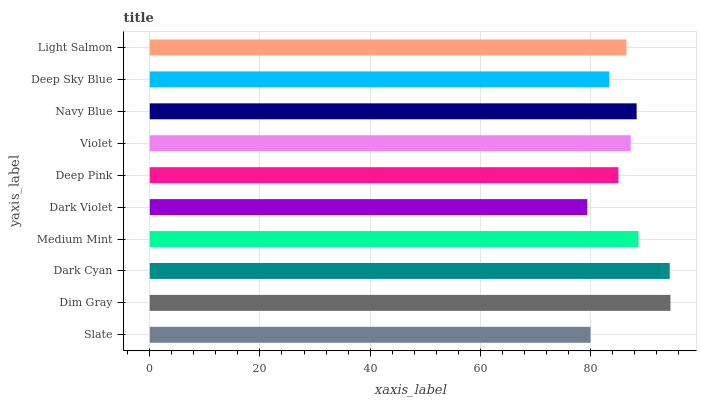Is Dark Violet the minimum?
Answer yes or no. Yes. Is Dim Gray the maximum?
Answer yes or no. Yes. Is Dark Cyan the minimum?
Answer yes or no. No. Is Dark Cyan the maximum?
Answer yes or no. No. Is Dim Gray greater than Dark Cyan?
Answer yes or no. Yes. Is Dark Cyan less than Dim Gray?
Answer yes or no. Yes. Is Dark Cyan greater than Dim Gray?
Answer yes or no. No. Is Dim Gray less than Dark Cyan?
Answer yes or no. No. Is Violet the high median?
Answer yes or no. Yes. Is Light Salmon the low median?
Answer yes or no. Yes. Is Deep Pink the high median?
Answer yes or no. No. Is Medium Mint the low median?
Answer yes or no. No. 